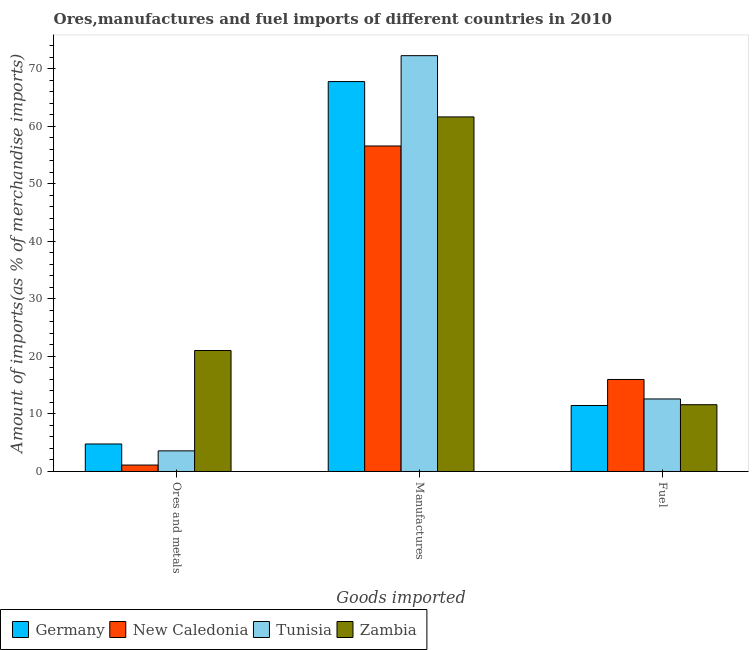How many groups of bars are there?
Provide a succinct answer. 3. Are the number of bars on each tick of the X-axis equal?
Your answer should be very brief. Yes. How many bars are there on the 3rd tick from the left?
Provide a short and direct response. 4. How many bars are there on the 1st tick from the right?
Provide a short and direct response. 4. What is the label of the 3rd group of bars from the left?
Provide a succinct answer. Fuel. What is the percentage of manufactures imports in Tunisia?
Offer a terse response. 72.29. Across all countries, what is the maximum percentage of fuel imports?
Keep it short and to the point. 16. Across all countries, what is the minimum percentage of ores and metals imports?
Provide a succinct answer. 1.12. In which country was the percentage of fuel imports maximum?
Provide a short and direct response. New Caledonia. In which country was the percentage of ores and metals imports minimum?
Make the answer very short. New Caledonia. What is the total percentage of fuel imports in the graph?
Make the answer very short. 51.69. What is the difference between the percentage of fuel imports in New Caledonia and that in Tunisia?
Provide a short and direct response. 3.39. What is the difference between the percentage of manufactures imports in Tunisia and the percentage of ores and metals imports in New Caledonia?
Keep it short and to the point. 71.18. What is the average percentage of ores and metals imports per country?
Offer a very short reply. 7.63. What is the difference between the percentage of fuel imports and percentage of manufactures imports in Germany?
Keep it short and to the point. -56.32. What is the ratio of the percentage of manufactures imports in Tunisia to that in Germany?
Keep it short and to the point. 1.07. Is the percentage of fuel imports in New Caledonia less than that in Zambia?
Your response must be concise. No. What is the difference between the highest and the second highest percentage of manufactures imports?
Keep it short and to the point. 4.5. What is the difference between the highest and the lowest percentage of fuel imports?
Your answer should be compact. 4.52. What does the 4th bar from the left in Manufactures represents?
Offer a terse response. Zambia. What does the 1st bar from the right in Fuel represents?
Your answer should be very brief. Zambia. What is the difference between two consecutive major ticks on the Y-axis?
Offer a terse response. 10. Does the graph contain grids?
Make the answer very short. No. Where does the legend appear in the graph?
Your answer should be very brief. Bottom left. What is the title of the graph?
Your answer should be very brief. Ores,manufactures and fuel imports of different countries in 2010. What is the label or title of the X-axis?
Make the answer very short. Goods imported. What is the label or title of the Y-axis?
Provide a short and direct response. Amount of imports(as % of merchandise imports). What is the Amount of imports(as % of merchandise imports) in Germany in Ores and metals?
Give a very brief answer. 4.78. What is the Amount of imports(as % of merchandise imports) in New Caledonia in Ores and metals?
Offer a terse response. 1.12. What is the Amount of imports(as % of merchandise imports) in Tunisia in Ores and metals?
Your answer should be compact. 3.58. What is the Amount of imports(as % of merchandise imports) in Zambia in Ores and metals?
Give a very brief answer. 21.03. What is the Amount of imports(as % of merchandise imports) in Germany in Manufactures?
Provide a succinct answer. 67.79. What is the Amount of imports(as % of merchandise imports) of New Caledonia in Manufactures?
Your answer should be compact. 56.59. What is the Amount of imports(as % of merchandise imports) in Tunisia in Manufactures?
Your answer should be very brief. 72.29. What is the Amount of imports(as % of merchandise imports) in Zambia in Manufactures?
Your answer should be very brief. 61.64. What is the Amount of imports(as % of merchandise imports) of Germany in Fuel?
Offer a very short reply. 11.47. What is the Amount of imports(as % of merchandise imports) of New Caledonia in Fuel?
Give a very brief answer. 16. What is the Amount of imports(as % of merchandise imports) in Tunisia in Fuel?
Your answer should be very brief. 12.61. What is the Amount of imports(as % of merchandise imports) in Zambia in Fuel?
Your answer should be very brief. 11.61. Across all Goods imported, what is the maximum Amount of imports(as % of merchandise imports) of Germany?
Make the answer very short. 67.79. Across all Goods imported, what is the maximum Amount of imports(as % of merchandise imports) in New Caledonia?
Your answer should be very brief. 56.59. Across all Goods imported, what is the maximum Amount of imports(as % of merchandise imports) of Tunisia?
Give a very brief answer. 72.29. Across all Goods imported, what is the maximum Amount of imports(as % of merchandise imports) in Zambia?
Offer a very short reply. 61.64. Across all Goods imported, what is the minimum Amount of imports(as % of merchandise imports) in Germany?
Provide a short and direct response. 4.78. Across all Goods imported, what is the minimum Amount of imports(as % of merchandise imports) of New Caledonia?
Offer a terse response. 1.12. Across all Goods imported, what is the minimum Amount of imports(as % of merchandise imports) in Tunisia?
Provide a short and direct response. 3.58. Across all Goods imported, what is the minimum Amount of imports(as % of merchandise imports) of Zambia?
Provide a short and direct response. 11.61. What is the total Amount of imports(as % of merchandise imports) in Germany in the graph?
Your response must be concise. 84.05. What is the total Amount of imports(as % of merchandise imports) in New Caledonia in the graph?
Ensure brevity in your answer.  73.7. What is the total Amount of imports(as % of merchandise imports) in Tunisia in the graph?
Ensure brevity in your answer.  88.49. What is the total Amount of imports(as % of merchandise imports) of Zambia in the graph?
Provide a succinct answer. 94.28. What is the difference between the Amount of imports(as % of merchandise imports) of Germany in Ores and metals and that in Manufactures?
Give a very brief answer. -63.01. What is the difference between the Amount of imports(as % of merchandise imports) of New Caledonia in Ores and metals and that in Manufactures?
Offer a terse response. -55.47. What is the difference between the Amount of imports(as % of merchandise imports) of Tunisia in Ores and metals and that in Manufactures?
Give a very brief answer. -68.71. What is the difference between the Amount of imports(as % of merchandise imports) of Zambia in Ores and metals and that in Manufactures?
Offer a terse response. -40.62. What is the difference between the Amount of imports(as % of merchandise imports) in Germany in Ores and metals and that in Fuel?
Give a very brief answer. -6.69. What is the difference between the Amount of imports(as % of merchandise imports) in New Caledonia in Ores and metals and that in Fuel?
Your response must be concise. -14.88. What is the difference between the Amount of imports(as % of merchandise imports) in Tunisia in Ores and metals and that in Fuel?
Your answer should be compact. -9.03. What is the difference between the Amount of imports(as % of merchandise imports) in Zambia in Ores and metals and that in Fuel?
Make the answer very short. 9.42. What is the difference between the Amount of imports(as % of merchandise imports) of Germany in Manufactures and that in Fuel?
Provide a succinct answer. 56.32. What is the difference between the Amount of imports(as % of merchandise imports) of New Caledonia in Manufactures and that in Fuel?
Provide a succinct answer. 40.59. What is the difference between the Amount of imports(as % of merchandise imports) in Tunisia in Manufactures and that in Fuel?
Give a very brief answer. 59.68. What is the difference between the Amount of imports(as % of merchandise imports) of Zambia in Manufactures and that in Fuel?
Offer a terse response. 50.03. What is the difference between the Amount of imports(as % of merchandise imports) of Germany in Ores and metals and the Amount of imports(as % of merchandise imports) of New Caledonia in Manufactures?
Provide a succinct answer. -51.81. What is the difference between the Amount of imports(as % of merchandise imports) of Germany in Ores and metals and the Amount of imports(as % of merchandise imports) of Tunisia in Manufactures?
Your response must be concise. -67.51. What is the difference between the Amount of imports(as % of merchandise imports) in Germany in Ores and metals and the Amount of imports(as % of merchandise imports) in Zambia in Manufactures?
Ensure brevity in your answer.  -56.86. What is the difference between the Amount of imports(as % of merchandise imports) in New Caledonia in Ores and metals and the Amount of imports(as % of merchandise imports) in Tunisia in Manufactures?
Provide a short and direct response. -71.18. What is the difference between the Amount of imports(as % of merchandise imports) in New Caledonia in Ores and metals and the Amount of imports(as % of merchandise imports) in Zambia in Manufactures?
Your answer should be very brief. -60.53. What is the difference between the Amount of imports(as % of merchandise imports) of Tunisia in Ores and metals and the Amount of imports(as % of merchandise imports) of Zambia in Manufactures?
Give a very brief answer. -58.06. What is the difference between the Amount of imports(as % of merchandise imports) of Germany in Ores and metals and the Amount of imports(as % of merchandise imports) of New Caledonia in Fuel?
Provide a short and direct response. -11.21. What is the difference between the Amount of imports(as % of merchandise imports) in Germany in Ores and metals and the Amount of imports(as % of merchandise imports) in Tunisia in Fuel?
Keep it short and to the point. -7.83. What is the difference between the Amount of imports(as % of merchandise imports) in Germany in Ores and metals and the Amount of imports(as % of merchandise imports) in Zambia in Fuel?
Provide a short and direct response. -6.83. What is the difference between the Amount of imports(as % of merchandise imports) of New Caledonia in Ores and metals and the Amount of imports(as % of merchandise imports) of Tunisia in Fuel?
Provide a succinct answer. -11.49. What is the difference between the Amount of imports(as % of merchandise imports) of New Caledonia in Ores and metals and the Amount of imports(as % of merchandise imports) of Zambia in Fuel?
Your answer should be compact. -10.49. What is the difference between the Amount of imports(as % of merchandise imports) in Tunisia in Ores and metals and the Amount of imports(as % of merchandise imports) in Zambia in Fuel?
Ensure brevity in your answer.  -8.03. What is the difference between the Amount of imports(as % of merchandise imports) of Germany in Manufactures and the Amount of imports(as % of merchandise imports) of New Caledonia in Fuel?
Your answer should be very brief. 51.8. What is the difference between the Amount of imports(as % of merchandise imports) in Germany in Manufactures and the Amount of imports(as % of merchandise imports) in Tunisia in Fuel?
Your answer should be compact. 55.18. What is the difference between the Amount of imports(as % of merchandise imports) of Germany in Manufactures and the Amount of imports(as % of merchandise imports) of Zambia in Fuel?
Provide a short and direct response. 56.18. What is the difference between the Amount of imports(as % of merchandise imports) in New Caledonia in Manufactures and the Amount of imports(as % of merchandise imports) in Tunisia in Fuel?
Offer a terse response. 43.98. What is the difference between the Amount of imports(as % of merchandise imports) of New Caledonia in Manufactures and the Amount of imports(as % of merchandise imports) of Zambia in Fuel?
Keep it short and to the point. 44.98. What is the difference between the Amount of imports(as % of merchandise imports) of Tunisia in Manufactures and the Amount of imports(as % of merchandise imports) of Zambia in Fuel?
Your answer should be compact. 60.68. What is the average Amount of imports(as % of merchandise imports) of Germany per Goods imported?
Ensure brevity in your answer.  28.02. What is the average Amount of imports(as % of merchandise imports) of New Caledonia per Goods imported?
Keep it short and to the point. 24.57. What is the average Amount of imports(as % of merchandise imports) of Tunisia per Goods imported?
Offer a very short reply. 29.5. What is the average Amount of imports(as % of merchandise imports) in Zambia per Goods imported?
Offer a very short reply. 31.43. What is the difference between the Amount of imports(as % of merchandise imports) in Germany and Amount of imports(as % of merchandise imports) in New Caledonia in Ores and metals?
Provide a short and direct response. 3.66. What is the difference between the Amount of imports(as % of merchandise imports) in Germany and Amount of imports(as % of merchandise imports) in Tunisia in Ores and metals?
Offer a terse response. 1.2. What is the difference between the Amount of imports(as % of merchandise imports) in Germany and Amount of imports(as % of merchandise imports) in Zambia in Ores and metals?
Offer a very short reply. -16.25. What is the difference between the Amount of imports(as % of merchandise imports) of New Caledonia and Amount of imports(as % of merchandise imports) of Tunisia in Ores and metals?
Offer a very short reply. -2.47. What is the difference between the Amount of imports(as % of merchandise imports) of New Caledonia and Amount of imports(as % of merchandise imports) of Zambia in Ores and metals?
Give a very brief answer. -19.91. What is the difference between the Amount of imports(as % of merchandise imports) of Tunisia and Amount of imports(as % of merchandise imports) of Zambia in Ores and metals?
Give a very brief answer. -17.45. What is the difference between the Amount of imports(as % of merchandise imports) of Germany and Amount of imports(as % of merchandise imports) of New Caledonia in Manufactures?
Offer a terse response. 11.2. What is the difference between the Amount of imports(as % of merchandise imports) in Germany and Amount of imports(as % of merchandise imports) in Tunisia in Manufactures?
Ensure brevity in your answer.  -4.5. What is the difference between the Amount of imports(as % of merchandise imports) in Germany and Amount of imports(as % of merchandise imports) in Zambia in Manufactures?
Provide a short and direct response. 6.15. What is the difference between the Amount of imports(as % of merchandise imports) in New Caledonia and Amount of imports(as % of merchandise imports) in Tunisia in Manufactures?
Your answer should be very brief. -15.7. What is the difference between the Amount of imports(as % of merchandise imports) in New Caledonia and Amount of imports(as % of merchandise imports) in Zambia in Manufactures?
Provide a short and direct response. -5.05. What is the difference between the Amount of imports(as % of merchandise imports) in Tunisia and Amount of imports(as % of merchandise imports) in Zambia in Manufactures?
Provide a short and direct response. 10.65. What is the difference between the Amount of imports(as % of merchandise imports) of Germany and Amount of imports(as % of merchandise imports) of New Caledonia in Fuel?
Give a very brief answer. -4.52. What is the difference between the Amount of imports(as % of merchandise imports) of Germany and Amount of imports(as % of merchandise imports) of Tunisia in Fuel?
Your answer should be very brief. -1.14. What is the difference between the Amount of imports(as % of merchandise imports) of Germany and Amount of imports(as % of merchandise imports) of Zambia in Fuel?
Offer a very short reply. -0.14. What is the difference between the Amount of imports(as % of merchandise imports) in New Caledonia and Amount of imports(as % of merchandise imports) in Tunisia in Fuel?
Keep it short and to the point. 3.39. What is the difference between the Amount of imports(as % of merchandise imports) of New Caledonia and Amount of imports(as % of merchandise imports) of Zambia in Fuel?
Provide a short and direct response. 4.39. What is the ratio of the Amount of imports(as % of merchandise imports) of Germany in Ores and metals to that in Manufactures?
Your answer should be very brief. 0.07. What is the ratio of the Amount of imports(as % of merchandise imports) in New Caledonia in Ores and metals to that in Manufactures?
Make the answer very short. 0.02. What is the ratio of the Amount of imports(as % of merchandise imports) in Tunisia in Ores and metals to that in Manufactures?
Offer a terse response. 0.05. What is the ratio of the Amount of imports(as % of merchandise imports) in Zambia in Ores and metals to that in Manufactures?
Provide a succinct answer. 0.34. What is the ratio of the Amount of imports(as % of merchandise imports) in Germany in Ores and metals to that in Fuel?
Provide a short and direct response. 0.42. What is the ratio of the Amount of imports(as % of merchandise imports) of New Caledonia in Ores and metals to that in Fuel?
Keep it short and to the point. 0.07. What is the ratio of the Amount of imports(as % of merchandise imports) of Tunisia in Ores and metals to that in Fuel?
Provide a succinct answer. 0.28. What is the ratio of the Amount of imports(as % of merchandise imports) in Zambia in Ores and metals to that in Fuel?
Make the answer very short. 1.81. What is the ratio of the Amount of imports(as % of merchandise imports) in Germany in Manufactures to that in Fuel?
Keep it short and to the point. 5.91. What is the ratio of the Amount of imports(as % of merchandise imports) of New Caledonia in Manufactures to that in Fuel?
Provide a succinct answer. 3.54. What is the ratio of the Amount of imports(as % of merchandise imports) of Tunisia in Manufactures to that in Fuel?
Offer a terse response. 5.73. What is the ratio of the Amount of imports(as % of merchandise imports) of Zambia in Manufactures to that in Fuel?
Make the answer very short. 5.31. What is the difference between the highest and the second highest Amount of imports(as % of merchandise imports) of Germany?
Offer a terse response. 56.32. What is the difference between the highest and the second highest Amount of imports(as % of merchandise imports) in New Caledonia?
Your response must be concise. 40.59. What is the difference between the highest and the second highest Amount of imports(as % of merchandise imports) of Tunisia?
Your response must be concise. 59.68. What is the difference between the highest and the second highest Amount of imports(as % of merchandise imports) of Zambia?
Make the answer very short. 40.62. What is the difference between the highest and the lowest Amount of imports(as % of merchandise imports) of Germany?
Ensure brevity in your answer.  63.01. What is the difference between the highest and the lowest Amount of imports(as % of merchandise imports) of New Caledonia?
Keep it short and to the point. 55.47. What is the difference between the highest and the lowest Amount of imports(as % of merchandise imports) of Tunisia?
Your answer should be very brief. 68.71. What is the difference between the highest and the lowest Amount of imports(as % of merchandise imports) of Zambia?
Ensure brevity in your answer.  50.03. 